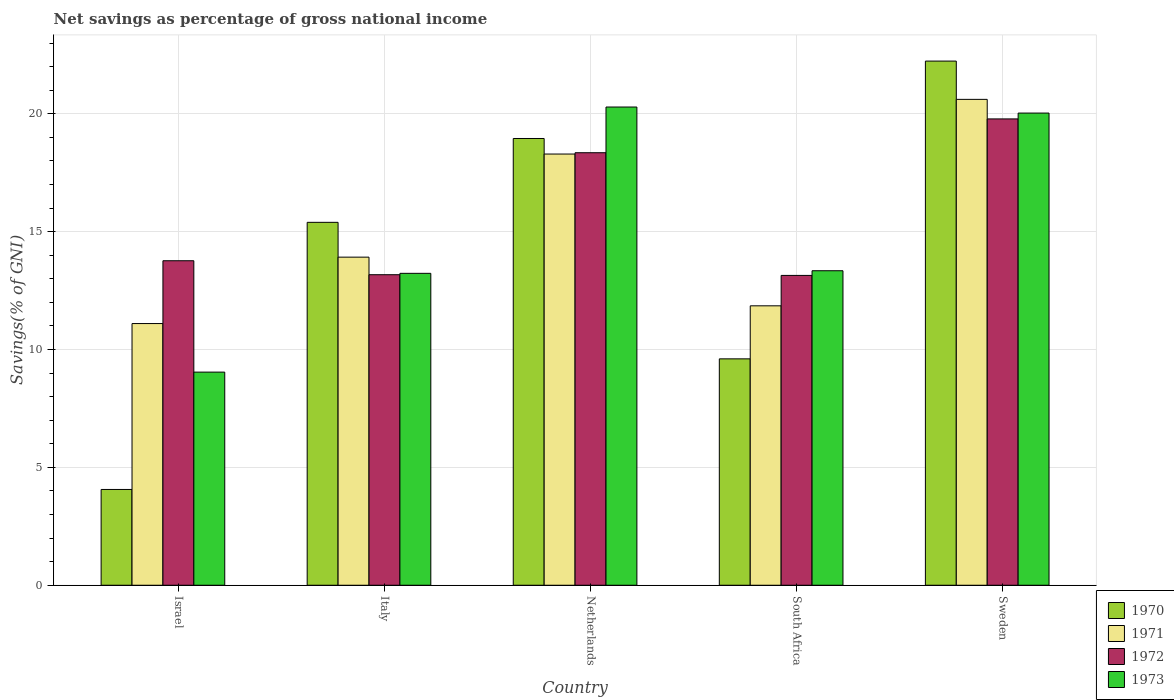How many different coloured bars are there?
Ensure brevity in your answer.  4. Are the number of bars per tick equal to the number of legend labels?
Make the answer very short. Yes. Are the number of bars on each tick of the X-axis equal?
Ensure brevity in your answer.  Yes. How many bars are there on the 5th tick from the right?
Your answer should be compact. 4. What is the label of the 5th group of bars from the left?
Your answer should be compact. Sweden. In how many cases, is the number of bars for a given country not equal to the number of legend labels?
Your response must be concise. 0. What is the total savings in 1971 in Italy?
Your answer should be very brief. 13.92. Across all countries, what is the maximum total savings in 1971?
Ensure brevity in your answer.  20.61. Across all countries, what is the minimum total savings in 1973?
Your answer should be very brief. 9.04. In which country was the total savings in 1972 minimum?
Your response must be concise. South Africa. What is the total total savings in 1971 in the graph?
Make the answer very short. 75.78. What is the difference between the total savings in 1970 in Netherlands and that in South Africa?
Give a very brief answer. 9.35. What is the difference between the total savings in 1973 in Netherlands and the total savings in 1972 in Sweden?
Offer a very short reply. 0.5. What is the average total savings in 1973 per country?
Your answer should be very brief. 15.19. What is the difference between the total savings of/in 1972 and total savings of/in 1970 in Italy?
Keep it short and to the point. -2.22. In how many countries, is the total savings in 1971 greater than 12 %?
Give a very brief answer. 3. What is the ratio of the total savings in 1973 in Italy to that in Netherlands?
Provide a succinct answer. 0.65. Is the total savings in 1971 in Israel less than that in Sweden?
Your answer should be compact. Yes. What is the difference between the highest and the second highest total savings in 1970?
Keep it short and to the point. -3.28. What is the difference between the highest and the lowest total savings in 1972?
Make the answer very short. 6.64. Is it the case that in every country, the sum of the total savings in 1973 and total savings in 1972 is greater than the total savings in 1971?
Your answer should be very brief. Yes. How many bars are there?
Your response must be concise. 20. Does the graph contain any zero values?
Provide a succinct answer. No. Does the graph contain grids?
Make the answer very short. Yes. Where does the legend appear in the graph?
Provide a short and direct response. Bottom right. How many legend labels are there?
Your response must be concise. 4. What is the title of the graph?
Keep it short and to the point. Net savings as percentage of gross national income. Does "1999" appear as one of the legend labels in the graph?
Offer a very short reply. No. What is the label or title of the X-axis?
Your response must be concise. Country. What is the label or title of the Y-axis?
Offer a terse response. Savings(% of GNI). What is the Savings(% of GNI) in 1970 in Israel?
Your answer should be compact. 4.06. What is the Savings(% of GNI) in 1971 in Israel?
Provide a short and direct response. 11.1. What is the Savings(% of GNI) in 1972 in Israel?
Offer a terse response. 13.77. What is the Savings(% of GNI) of 1973 in Israel?
Offer a very short reply. 9.04. What is the Savings(% of GNI) of 1970 in Italy?
Your answer should be very brief. 15.4. What is the Savings(% of GNI) in 1971 in Italy?
Provide a short and direct response. 13.92. What is the Savings(% of GNI) of 1972 in Italy?
Ensure brevity in your answer.  13.17. What is the Savings(% of GNI) of 1973 in Italy?
Ensure brevity in your answer.  13.23. What is the Savings(% of GNI) in 1970 in Netherlands?
Make the answer very short. 18.95. What is the Savings(% of GNI) of 1971 in Netherlands?
Keep it short and to the point. 18.29. What is the Savings(% of GNI) of 1972 in Netherlands?
Your answer should be very brief. 18.35. What is the Savings(% of GNI) in 1973 in Netherlands?
Ensure brevity in your answer.  20.29. What is the Savings(% of GNI) of 1970 in South Africa?
Your answer should be compact. 9.6. What is the Savings(% of GNI) of 1971 in South Africa?
Offer a very short reply. 11.85. What is the Savings(% of GNI) in 1972 in South Africa?
Make the answer very short. 13.14. What is the Savings(% of GNI) in 1973 in South Africa?
Your answer should be compact. 13.34. What is the Savings(% of GNI) in 1970 in Sweden?
Your answer should be compact. 22.24. What is the Savings(% of GNI) in 1971 in Sweden?
Ensure brevity in your answer.  20.61. What is the Savings(% of GNI) in 1972 in Sweden?
Provide a succinct answer. 19.78. What is the Savings(% of GNI) of 1973 in Sweden?
Your response must be concise. 20.03. Across all countries, what is the maximum Savings(% of GNI) in 1970?
Offer a terse response. 22.24. Across all countries, what is the maximum Savings(% of GNI) of 1971?
Offer a terse response. 20.61. Across all countries, what is the maximum Savings(% of GNI) in 1972?
Offer a very short reply. 19.78. Across all countries, what is the maximum Savings(% of GNI) of 1973?
Your response must be concise. 20.29. Across all countries, what is the minimum Savings(% of GNI) in 1970?
Provide a succinct answer. 4.06. Across all countries, what is the minimum Savings(% of GNI) of 1971?
Make the answer very short. 11.1. Across all countries, what is the minimum Savings(% of GNI) in 1972?
Give a very brief answer. 13.14. Across all countries, what is the minimum Savings(% of GNI) in 1973?
Make the answer very short. 9.04. What is the total Savings(% of GNI) of 1970 in the graph?
Provide a short and direct response. 70.25. What is the total Savings(% of GNI) in 1971 in the graph?
Offer a very short reply. 75.78. What is the total Savings(% of GNI) in 1972 in the graph?
Keep it short and to the point. 78.22. What is the total Savings(% of GNI) in 1973 in the graph?
Provide a short and direct response. 75.93. What is the difference between the Savings(% of GNI) in 1970 in Israel and that in Italy?
Provide a short and direct response. -11.33. What is the difference between the Savings(% of GNI) in 1971 in Israel and that in Italy?
Your response must be concise. -2.82. What is the difference between the Savings(% of GNI) of 1972 in Israel and that in Italy?
Ensure brevity in your answer.  0.59. What is the difference between the Savings(% of GNI) in 1973 in Israel and that in Italy?
Provide a succinct answer. -4.19. What is the difference between the Savings(% of GNI) of 1970 in Israel and that in Netherlands?
Ensure brevity in your answer.  -14.89. What is the difference between the Savings(% of GNI) of 1971 in Israel and that in Netherlands?
Offer a very short reply. -7.19. What is the difference between the Savings(% of GNI) of 1972 in Israel and that in Netherlands?
Offer a very short reply. -4.58. What is the difference between the Savings(% of GNI) in 1973 in Israel and that in Netherlands?
Make the answer very short. -11.25. What is the difference between the Savings(% of GNI) in 1970 in Israel and that in South Africa?
Provide a succinct answer. -5.54. What is the difference between the Savings(% of GNI) of 1971 in Israel and that in South Africa?
Offer a terse response. -0.75. What is the difference between the Savings(% of GNI) of 1972 in Israel and that in South Africa?
Provide a short and direct response. 0.62. What is the difference between the Savings(% of GNI) of 1973 in Israel and that in South Africa?
Ensure brevity in your answer.  -4.3. What is the difference between the Savings(% of GNI) in 1970 in Israel and that in Sweden?
Your answer should be very brief. -18.17. What is the difference between the Savings(% of GNI) of 1971 in Israel and that in Sweden?
Give a very brief answer. -9.51. What is the difference between the Savings(% of GNI) in 1972 in Israel and that in Sweden?
Offer a terse response. -6.02. What is the difference between the Savings(% of GNI) in 1973 in Israel and that in Sweden?
Your answer should be very brief. -10.99. What is the difference between the Savings(% of GNI) in 1970 in Italy and that in Netherlands?
Your response must be concise. -3.56. What is the difference between the Savings(% of GNI) in 1971 in Italy and that in Netherlands?
Give a very brief answer. -4.37. What is the difference between the Savings(% of GNI) of 1972 in Italy and that in Netherlands?
Offer a terse response. -5.18. What is the difference between the Savings(% of GNI) in 1973 in Italy and that in Netherlands?
Give a very brief answer. -7.06. What is the difference between the Savings(% of GNI) in 1970 in Italy and that in South Africa?
Your answer should be compact. 5.79. What is the difference between the Savings(% of GNI) of 1971 in Italy and that in South Africa?
Your answer should be compact. 2.07. What is the difference between the Savings(% of GNI) of 1972 in Italy and that in South Africa?
Provide a short and direct response. 0.03. What is the difference between the Savings(% of GNI) of 1973 in Italy and that in South Africa?
Provide a succinct answer. -0.11. What is the difference between the Savings(% of GNI) in 1970 in Italy and that in Sweden?
Your answer should be very brief. -6.84. What is the difference between the Savings(% of GNI) in 1971 in Italy and that in Sweden?
Provide a succinct answer. -6.69. What is the difference between the Savings(% of GNI) in 1972 in Italy and that in Sweden?
Your response must be concise. -6.61. What is the difference between the Savings(% of GNI) in 1973 in Italy and that in Sweden?
Offer a terse response. -6.8. What is the difference between the Savings(% of GNI) of 1970 in Netherlands and that in South Africa?
Give a very brief answer. 9.35. What is the difference between the Savings(% of GNI) of 1971 in Netherlands and that in South Africa?
Keep it short and to the point. 6.44. What is the difference between the Savings(% of GNI) of 1972 in Netherlands and that in South Africa?
Your answer should be compact. 5.21. What is the difference between the Savings(% of GNI) in 1973 in Netherlands and that in South Africa?
Offer a very short reply. 6.95. What is the difference between the Savings(% of GNI) of 1970 in Netherlands and that in Sweden?
Your answer should be compact. -3.28. What is the difference between the Savings(% of GNI) in 1971 in Netherlands and that in Sweden?
Your answer should be compact. -2.32. What is the difference between the Savings(% of GNI) of 1972 in Netherlands and that in Sweden?
Ensure brevity in your answer.  -1.43. What is the difference between the Savings(% of GNI) of 1973 in Netherlands and that in Sweden?
Give a very brief answer. 0.26. What is the difference between the Savings(% of GNI) of 1970 in South Africa and that in Sweden?
Your answer should be very brief. -12.63. What is the difference between the Savings(% of GNI) of 1971 in South Africa and that in Sweden?
Your answer should be compact. -8.76. What is the difference between the Savings(% of GNI) of 1972 in South Africa and that in Sweden?
Make the answer very short. -6.64. What is the difference between the Savings(% of GNI) of 1973 in South Africa and that in Sweden?
Provide a short and direct response. -6.69. What is the difference between the Savings(% of GNI) of 1970 in Israel and the Savings(% of GNI) of 1971 in Italy?
Provide a short and direct response. -9.86. What is the difference between the Savings(% of GNI) of 1970 in Israel and the Savings(% of GNI) of 1972 in Italy?
Your answer should be very brief. -9.11. What is the difference between the Savings(% of GNI) in 1970 in Israel and the Savings(% of GNI) in 1973 in Italy?
Your answer should be very brief. -9.17. What is the difference between the Savings(% of GNI) of 1971 in Israel and the Savings(% of GNI) of 1972 in Italy?
Provide a short and direct response. -2.07. What is the difference between the Savings(% of GNI) in 1971 in Israel and the Savings(% of GNI) in 1973 in Italy?
Provide a succinct answer. -2.13. What is the difference between the Savings(% of GNI) of 1972 in Israel and the Savings(% of GNI) of 1973 in Italy?
Provide a short and direct response. 0.53. What is the difference between the Savings(% of GNI) of 1970 in Israel and the Savings(% of GNI) of 1971 in Netherlands?
Make the answer very short. -14.23. What is the difference between the Savings(% of GNI) of 1970 in Israel and the Savings(% of GNI) of 1972 in Netherlands?
Provide a short and direct response. -14.29. What is the difference between the Savings(% of GNI) in 1970 in Israel and the Savings(% of GNI) in 1973 in Netherlands?
Offer a very short reply. -16.22. What is the difference between the Savings(% of GNI) of 1971 in Israel and the Savings(% of GNI) of 1972 in Netherlands?
Keep it short and to the point. -7.25. What is the difference between the Savings(% of GNI) of 1971 in Israel and the Savings(% of GNI) of 1973 in Netherlands?
Make the answer very short. -9.19. What is the difference between the Savings(% of GNI) in 1972 in Israel and the Savings(% of GNI) in 1973 in Netherlands?
Your answer should be very brief. -6.52. What is the difference between the Savings(% of GNI) in 1970 in Israel and the Savings(% of GNI) in 1971 in South Africa?
Your answer should be very brief. -7.79. What is the difference between the Savings(% of GNI) of 1970 in Israel and the Savings(% of GNI) of 1972 in South Africa?
Ensure brevity in your answer.  -9.08. What is the difference between the Savings(% of GNI) in 1970 in Israel and the Savings(% of GNI) in 1973 in South Africa?
Ensure brevity in your answer.  -9.28. What is the difference between the Savings(% of GNI) of 1971 in Israel and the Savings(% of GNI) of 1972 in South Africa?
Give a very brief answer. -2.04. What is the difference between the Savings(% of GNI) of 1971 in Israel and the Savings(% of GNI) of 1973 in South Africa?
Provide a succinct answer. -2.24. What is the difference between the Savings(% of GNI) of 1972 in Israel and the Savings(% of GNI) of 1973 in South Africa?
Give a very brief answer. 0.42. What is the difference between the Savings(% of GNI) of 1970 in Israel and the Savings(% of GNI) of 1971 in Sweden?
Ensure brevity in your answer.  -16.55. What is the difference between the Savings(% of GNI) in 1970 in Israel and the Savings(% of GNI) in 1972 in Sweden?
Provide a short and direct response. -15.72. What is the difference between the Savings(% of GNI) of 1970 in Israel and the Savings(% of GNI) of 1973 in Sweden?
Offer a terse response. -15.97. What is the difference between the Savings(% of GNI) of 1971 in Israel and the Savings(% of GNI) of 1972 in Sweden?
Keep it short and to the point. -8.68. What is the difference between the Savings(% of GNI) of 1971 in Israel and the Savings(% of GNI) of 1973 in Sweden?
Give a very brief answer. -8.93. What is the difference between the Savings(% of GNI) in 1972 in Israel and the Savings(% of GNI) in 1973 in Sweden?
Keep it short and to the point. -6.27. What is the difference between the Savings(% of GNI) in 1970 in Italy and the Savings(% of GNI) in 1971 in Netherlands?
Offer a terse response. -2.9. What is the difference between the Savings(% of GNI) in 1970 in Italy and the Savings(% of GNI) in 1972 in Netherlands?
Your answer should be very brief. -2.95. What is the difference between the Savings(% of GNI) of 1970 in Italy and the Savings(% of GNI) of 1973 in Netherlands?
Your answer should be compact. -4.89. What is the difference between the Savings(% of GNI) of 1971 in Italy and the Savings(% of GNI) of 1972 in Netherlands?
Offer a very short reply. -4.43. What is the difference between the Savings(% of GNI) in 1971 in Italy and the Savings(% of GNI) in 1973 in Netherlands?
Provide a short and direct response. -6.37. What is the difference between the Savings(% of GNI) in 1972 in Italy and the Savings(% of GNI) in 1973 in Netherlands?
Your answer should be very brief. -7.11. What is the difference between the Savings(% of GNI) of 1970 in Italy and the Savings(% of GNI) of 1971 in South Africa?
Provide a short and direct response. 3.54. What is the difference between the Savings(% of GNI) in 1970 in Italy and the Savings(% of GNI) in 1972 in South Africa?
Your answer should be very brief. 2.25. What is the difference between the Savings(% of GNI) of 1970 in Italy and the Savings(% of GNI) of 1973 in South Africa?
Your response must be concise. 2.05. What is the difference between the Savings(% of GNI) in 1971 in Italy and the Savings(% of GNI) in 1972 in South Africa?
Your answer should be very brief. 0.78. What is the difference between the Savings(% of GNI) in 1971 in Italy and the Savings(% of GNI) in 1973 in South Africa?
Your answer should be very brief. 0.58. What is the difference between the Savings(% of GNI) of 1972 in Italy and the Savings(% of GNI) of 1973 in South Africa?
Offer a very short reply. -0.17. What is the difference between the Savings(% of GNI) in 1970 in Italy and the Savings(% of GNI) in 1971 in Sweden?
Your response must be concise. -5.22. What is the difference between the Savings(% of GNI) in 1970 in Italy and the Savings(% of GNI) in 1972 in Sweden?
Make the answer very short. -4.39. What is the difference between the Savings(% of GNI) of 1970 in Italy and the Savings(% of GNI) of 1973 in Sweden?
Offer a very short reply. -4.64. What is the difference between the Savings(% of GNI) in 1971 in Italy and the Savings(% of GNI) in 1972 in Sweden?
Provide a short and direct response. -5.86. What is the difference between the Savings(% of GNI) of 1971 in Italy and the Savings(% of GNI) of 1973 in Sweden?
Your answer should be very brief. -6.11. What is the difference between the Savings(% of GNI) of 1972 in Italy and the Savings(% of GNI) of 1973 in Sweden?
Your response must be concise. -6.86. What is the difference between the Savings(% of GNI) in 1970 in Netherlands and the Savings(% of GNI) in 1971 in South Africa?
Your answer should be very brief. 7.1. What is the difference between the Savings(% of GNI) of 1970 in Netherlands and the Savings(% of GNI) of 1972 in South Africa?
Your answer should be compact. 5.81. What is the difference between the Savings(% of GNI) in 1970 in Netherlands and the Savings(% of GNI) in 1973 in South Africa?
Offer a terse response. 5.61. What is the difference between the Savings(% of GNI) in 1971 in Netherlands and the Savings(% of GNI) in 1972 in South Africa?
Offer a terse response. 5.15. What is the difference between the Savings(% of GNI) of 1971 in Netherlands and the Savings(% of GNI) of 1973 in South Africa?
Ensure brevity in your answer.  4.95. What is the difference between the Savings(% of GNI) in 1972 in Netherlands and the Savings(% of GNI) in 1973 in South Africa?
Provide a succinct answer. 5.01. What is the difference between the Savings(% of GNI) of 1970 in Netherlands and the Savings(% of GNI) of 1971 in Sweden?
Offer a very short reply. -1.66. What is the difference between the Savings(% of GNI) in 1970 in Netherlands and the Savings(% of GNI) in 1972 in Sweden?
Your response must be concise. -0.83. What is the difference between the Savings(% of GNI) of 1970 in Netherlands and the Savings(% of GNI) of 1973 in Sweden?
Provide a short and direct response. -1.08. What is the difference between the Savings(% of GNI) of 1971 in Netherlands and the Savings(% of GNI) of 1972 in Sweden?
Ensure brevity in your answer.  -1.49. What is the difference between the Savings(% of GNI) in 1971 in Netherlands and the Savings(% of GNI) in 1973 in Sweden?
Offer a very short reply. -1.74. What is the difference between the Savings(% of GNI) of 1972 in Netherlands and the Savings(% of GNI) of 1973 in Sweden?
Provide a short and direct response. -1.68. What is the difference between the Savings(% of GNI) of 1970 in South Africa and the Savings(% of GNI) of 1971 in Sweden?
Ensure brevity in your answer.  -11.01. What is the difference between the Savings(% of GNI) of 1970 in South Africa and the Savings(% of GNI) of 1972 in Sweden?
Provide a short and direct response. -10.18. What is the difference between the Savings(% of GNI) in 1970 in South Africa and the Savings(% of GNI) in 1973 in Sweden?
Offer a very short reply. -10.43. What is the difference between the Savings(% of GNI) of 1971 in South Africa and the Savings(% of GNI) of 1972 in Sweden?
Give a very brief answer. -7.93. What is the difference between the Savings(% of GNI) of 1971 in South Africa and the Savings(% of GNI) of 1973 in Sweden?
Your answer should be compact. -8.18. What is the difference between the Savings(% of GNI) in 1972 in South Africa and the Savings(% of GNI) in 1973 in Sweden?
Provide a short and direct response. -6.89. What is the average Savings(% of GNI) of 1970 per country?
Offer a very short reply. 14.05. What is the average Savings(% of GNI) of 1971 per country?
Your answer should be compact. 15.16. What is the average Savings(% of GNI) of 1972 per country?
Offer a terse response. 15.64. What is the average Savings(% of GNI) in 1973 per country?
Keep it short and to the point. 15.19. What is the difference between the Savings(% of GNI) of 1970 and Savings(% of GNI) of 1971 in Israel?
Your answer should be very brief. -7.04. What is the difference between the Savings(% of GNI) of 1970 and Savings(% of GNI) of 1972 in Israel?
Your answer should be compact. -9.7. What is the difference between the Savings(% of GNI) in 1970 and Savings(% of GNI) in 1973 in Israel?
Provide a short and direct response. -4.98. What is the difference between the Savings(% of GNI) in 1971 and Savings(% of GNI) in 1972 in Israel?
Give a very brief answer. -2.66. What is the difference between the Savings(% of GNI) in 1971 and Savings(% of GNI) in 1973 in Israel?
Provide a succinct answer. 2.06. What is the difference between the Savings(% of GNI) in 1972 and Savings(% of GNI) in 1973 in Israel?
Offer a terse response. 4.73. What is the difference between the Savings(% of GNI) of 1970 and Savings(% of GNI) of 1971 in Italy?
Keep it short and to the point. 1.48. What is the difference between the Savings(% of GNI) of 1970 and Savings(% of GNI) of 1972 in Italy?
Offer a very short reply. 2.22. What is the difference between the Savings(% of GNI) of 1970 and Savings(% of GNI) of 1973 in Italy?
Your response must be concise. 2.16. What is the difference between the Savings(% of GNI) in 1971 and Savings(% of GNI) in 1972 in Italy?
Your answer should be very brief. 0.75. What is the difference between the Savings(% of GNI) in 1971 and Savings(% of GNI) in 1973 in Italy?
Keep it short and to the point. 0.69. What is the difference between the Savings(% of GNI) of 1972 and Savings(% of GNI) of 1973 in Italy?
Provide a succinct answer. -0.06. What is the difference between the Savings(% of GNI) in 1970 and Savings(% of GNI) in 1971 in Netherlands?
Your answer should be very brief. 0.66. What is the difference between the Savings(% of GNI) in 1970 and Savings(% of GNI) in 1972 in Netherlands?
Give a very brief answer. 0.6. What is the difference between the Savings(% of GNI) of 1970 and Savings(% of GNI) of 1973 in Netherlands?
Provide a succinct answer. -1.33. What is the difference between the Savings(% of GNI) of 1971 and Savings(% of GNI) of 1972 in Netherlands?
Keep it short and to the point. -0.06. What is the difference between the Savings(% of GNI) in 1971 and Savings(% of GNI) in 1973 in Netherlands?
Ensure brevity in your answer.  -1.99. What is the difference between the Savings(% of GNI) in 1972 and Savings(% of GNI) in 1973 in Netherlands?
Your answer should be very brief. -1.94. What is the difference between the Savings(% of GNI) of 1970 and Savings(% of GNI) of 1971 in South Africa?
Ensure brevity in your answer.  -2.25. What is the difference between the Savings(% of GNI) of 1970 and Savings(% of GNI) of 1972 in South Africa?
Your response must be concise. -3.54. What is the difference between the Savings(% of GNI) of 1970 and Savings(% of GNI) of 1973 in South Africa?
Provide a succinct answer. -3.74. What is the difference between the Savings(% of GNI) of 1971 and Savings(% of GNI) of 1972 in South Africa?
Provide a succinct answer. -1.29. What is the difference between the Savings(% of GNI) of 1971 and Savings(% of GNI) of 1973 in South Africa?
Your answer should be very brief. -1.49. What is the difference between the Savings(% of GNI) of 1972 and Savings(% of GNI) of 1973 in South Africa?
Keep it short and to the point. -0.2. What is the difference between the Savings(% of GNI) of 1970 and Savings(% of GNI) of 1971 in Sweden?
Your response must be concise. 1.62. What is the difference between the Savings(% of GNI) of 1970 and Savings(% of GNI) of 1972 in Sweden?
Your answer should be compact. 2.45. What is the difference between the Savings(% of GNI) of 1970 and Savings(% of GNI) of 1973 in Sweden?
Give a very brief answer. 2.21. What is the difference between the Savings(% of GNI) of 1971 and Savings(% of GNI) of 1972 in Sweden?
Keep it short and to the point. 0.83. What is the difference between the Savings(% of GNI) in 1971 and Savings(% of GNI) in 1973 in Sweden?
Your answer should be very brief. 0.58. What is the difference between the Savings(% of GNI) in 1972 and Savings(% of GNI) in 1973 in Sweden?
Provide a succinct answer. -0.25. What is the ratio of the Savings(% of GNI) of 1970 in Israel to that in Italy?
Ensure brevity in your answer.  0.26. What is the ratio of the Savings(% of GNI) of 1971 in Israel to that in Italy?
Make the answer very short. 0.8. What is the ratio of the Savings(% of GNI) of 1972 in Israel to that in Italy?
Your response must be concise. 1.04. What is the ratio of the Savings(% of GNI) of 1973 in Israel to that in Italy?
Make the answer very short. 0.68. What is the ratio of the Savings(% of GNI) in 1970 in Israel to that in Netherlands?
Offer a very short reply. 0.21. What is the ratio of the Savings(% of GNI) in 1971 in Israel to that in Netherlands?
Ensure brevity in your answer.  0.61. What is the ratio of the Savings(% of GNI) of 1972 in Israel to that in Netherlands?
Provide a succinct answer. 0.75. What is the ratio of the Savings(% of GNI) in 1973 in Israel to that in Netherlands?
Make the answer very short. 0.45. What is the ratio of the Savings(% of GNI) of 1970 in Israel to that in South Africa?
Make the answer very short. 0.42. What is the ratio of the Savings(% of GNI) in 1971 in Israel to that in South Africa?
Your answer should be compact. 0.94. What is the ratio of the Savings(% of GNI) of 1972 in Israel to that in South Africa?
Give a very brief answer. 1.05. What is the ratio of the Savings(% of GNI) in 1973 in Israel to that in South Africa?
Offer a terse response. 0.68. What is the ratio of the Savings(% of GNI) of 1970 in Israel to that in Sweden?
Your answer should be compact. 0.18. What is the ratio of the Savings(% of GNI) of 1971 in Israel to that in Sweden?
Provide a short and direct response. 0.54. What is the ratio of the Savings(% of GNI) in 1972 in Israel to that in Sweden?
Offer a very short reply. 0.7. What is the ratio of the Savings(% of GNI) of 1973 in Israel to that in Sweden?
Offer a very short reply. 0.45. What is the ratio of the Savings(% of GNI) of 1970 in Italy to that in Netherlands?
Make the answer very short. 0.81. What is the ratio of the Savings(% of GNI) of 1971 in Italy to that in Netherlands?
Keep it short and to the point. 0.76. What is the ratio of the Savings(% of GNI) of 1972 in Italy to that in Netherlands?
Make the answer very short. 0.72. What is the ratio of the Savings(% of GNI) of 1973 in Italy to that in Netherlands?
Ensure brevity in your answer.  0.65. What is the ratio of the Savings(% of GNI) in 1970 in Italy to that in South Africa?
Provide a short and direct response. 1.6. What is the ratio of the Savings(% of GNI) of 1971 in Italy to that in South Africa?
Provide a succinct answer. 1.17. What is the ratio of the Savings(% of GNI) in 1970 in Italy to that in Sweden?
Offer a terse response. 0.69. What is the ratio of the Savings(% of GNI) of 1971 in Italy to that in Sweden?
Your answer should be very brief. 0.68. What is the ratio of the Savings(% of GNI) of 1972 in Italy to that in Sweden?
Your answer should be very brief. 0.67. What is the ratio of the Savings(% of GNI) of 1973 in Italy to that in Sweden?
Give a very brief answer. 0.66. What is the ratio of the Savings(% of GNI) of 1970 in Netherlands to that in South Africa?
Make the answer very short. 1.97. What is the ratio of the Savings(% of GNI) of 1971 in Netherlands to that in South Africa?
Your answer should be compact. 1.54. What is the ratio of the Savings(% of GNI) in 1972 in Netherlands to that in South Africa?
Provide a succinct answer. 1.4. What is the ratio of the Savings(% of GNI) in 1973 in Netherlands to that in South Africa?
Ensure brevity in your answer.  1.52. What is the ratio of the Savings(% of GNI) of 1970 in Netherlands to that in Sweden?
Provide a succinct answer. 0.85. What is the ratio of the Savings(% of GNI) in 1971 in Netherlands to that in Sweden?
Your answer should be very brief. 0.89. What is the ratio of the Savings(% of GNI) of 1972 in Netherlands to that in Sweden?
Provide a succinct answer. 0.93. What is the ratio of the Savings(% of GNI) in 1973 in Netherlands to that in Sweden?
Keep it short and to the point. 1.01. What is the ratio of the Savings(% of GNI) in 1970 in South Africa to that in Sweden?
Provide a short and direct response. 0.43. What is the ratio of the Savings(% of GNI) in 1971 in South Africa to that in Sweden?
Keep it short and to the point. 0.58. What is the ratio of the Savings(% of GNI) of 1972 in South Africa to that in Sweden?
Your answer should be very brief. 0.66. What is the ratio of the Savings(% of GNI) in 1973 in South Africa to that in Sweden?
Your response must be concise. 0.67. What is the difference between the highest and the second highest Savings(% of GNI) in 1970?
Offer a terse response. 3.28. What is the difference between the highest and the second highest Savings(% of GNI) of 1971?
Offer a very short reply. 2.32. What is the difference between the highest and the second highest Savings(% of GNI) of 1972?
Provide a succinct answer. 1.43. What is the difference between the highest and the second highest Savings(% of GNI) of 1973?
Your answer should be compact. 0.26. What is the difference between the highest and the lowest Savings(% of GNI) in 1970?
Give a very brief answer. 18.17. What is the difference between the highest and the lowest Savings(% of GNI) in 1971?
Your answer should be compact. 9.51. What is the difference between the highest and the lowest Savings(% of GNI) of 1972?
Make the answer very short. 6.64. What is the difference between the highest and the lowest Savings(% of GNI) of 1973?
Offer a very short reply. 11.25. 